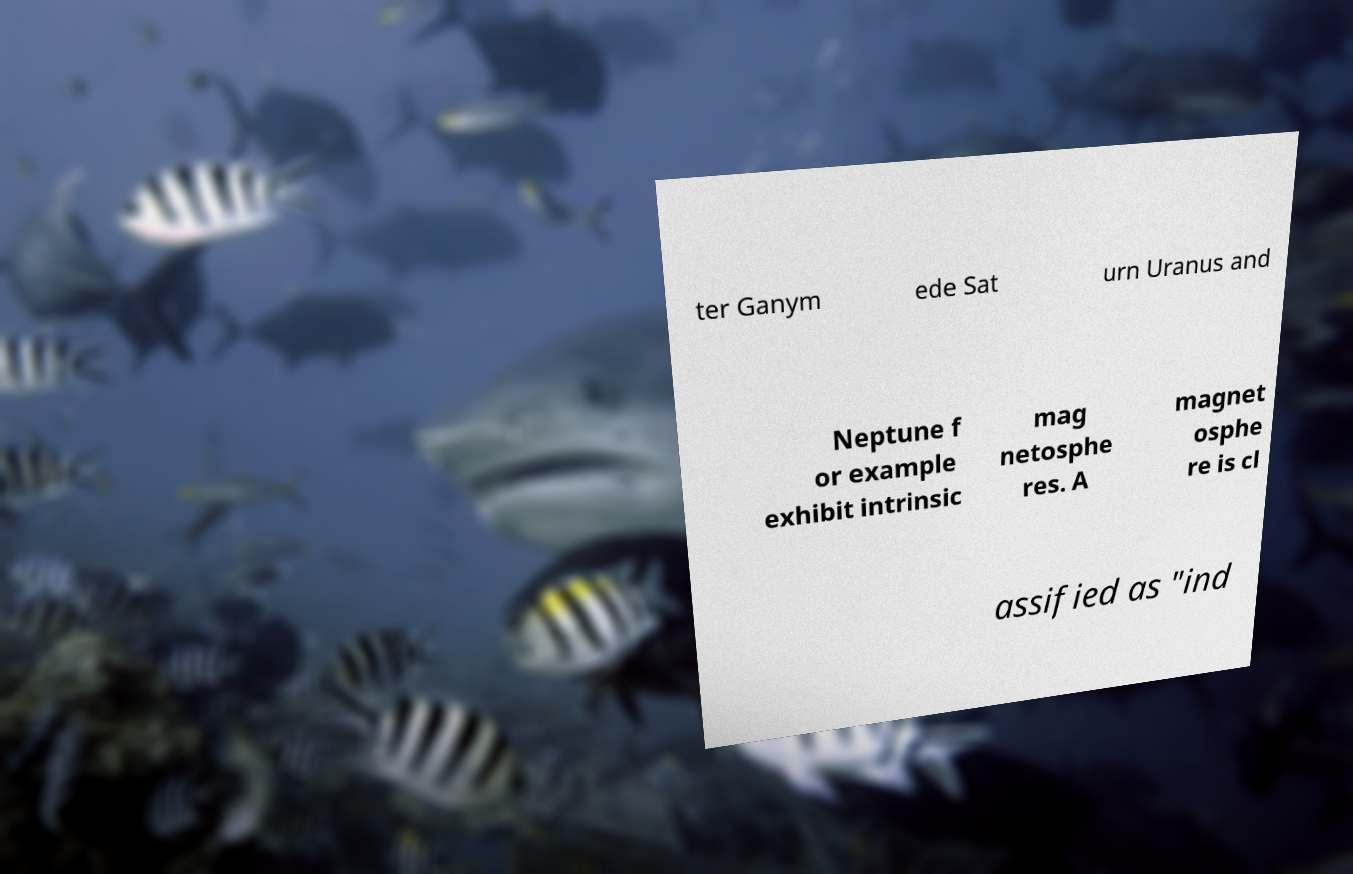What messages or text are displayed in this image? I need them in a readable, typed format. ter Ganym ede Sat urn Uranus and Neptune f or example exhibit intrinsic mag netosphe res. A magnet osphe re is cl assified as "ind 